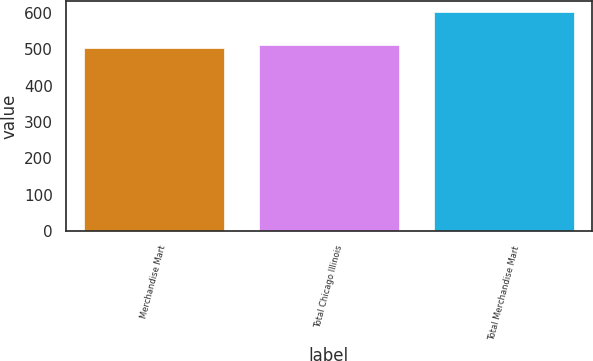Convert chart to OTSL. <chart><loc_0><loc_0><loc_500><loc_500><bar_chart><fcel>Merchandise Mart<fcel>Total Chicago Illinois<fcel>Total Merchandise Mart<nl><fcel>502<fcel>512.1<fcel>603<nl></chart> 